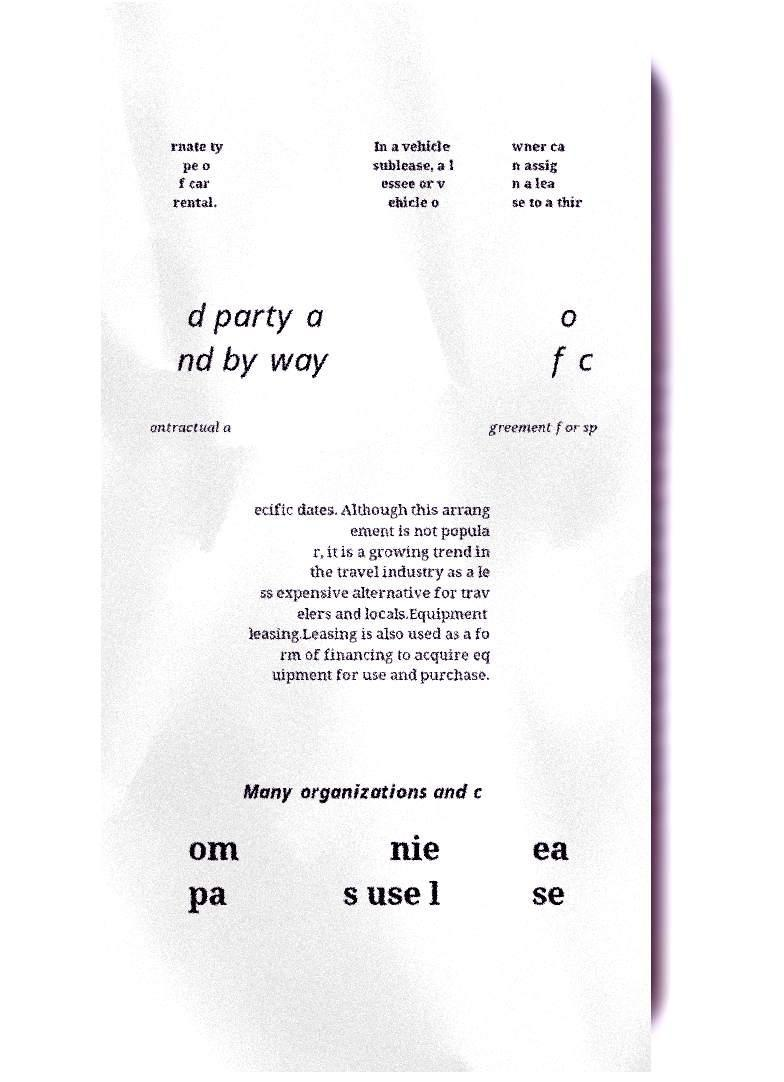Please identify and transcribe the text found in this image. rnate ty pe o f car rental. In a vehicle sublease, a l essee or v ehicle o wner ca n assig n a lea se to a thir d party a nd by way o f c ontractual a greement for sp ecific dates. Although this arrang ement is not popula r, it is a growing trend in the travel industry as a le ss expensive alternative for trav elers and locals.Equipment leasing.Leasing is also used as a fo rm of financing to acquire eq uipment for use and purchase. Many organizations and c om pa nie s use l ea se 